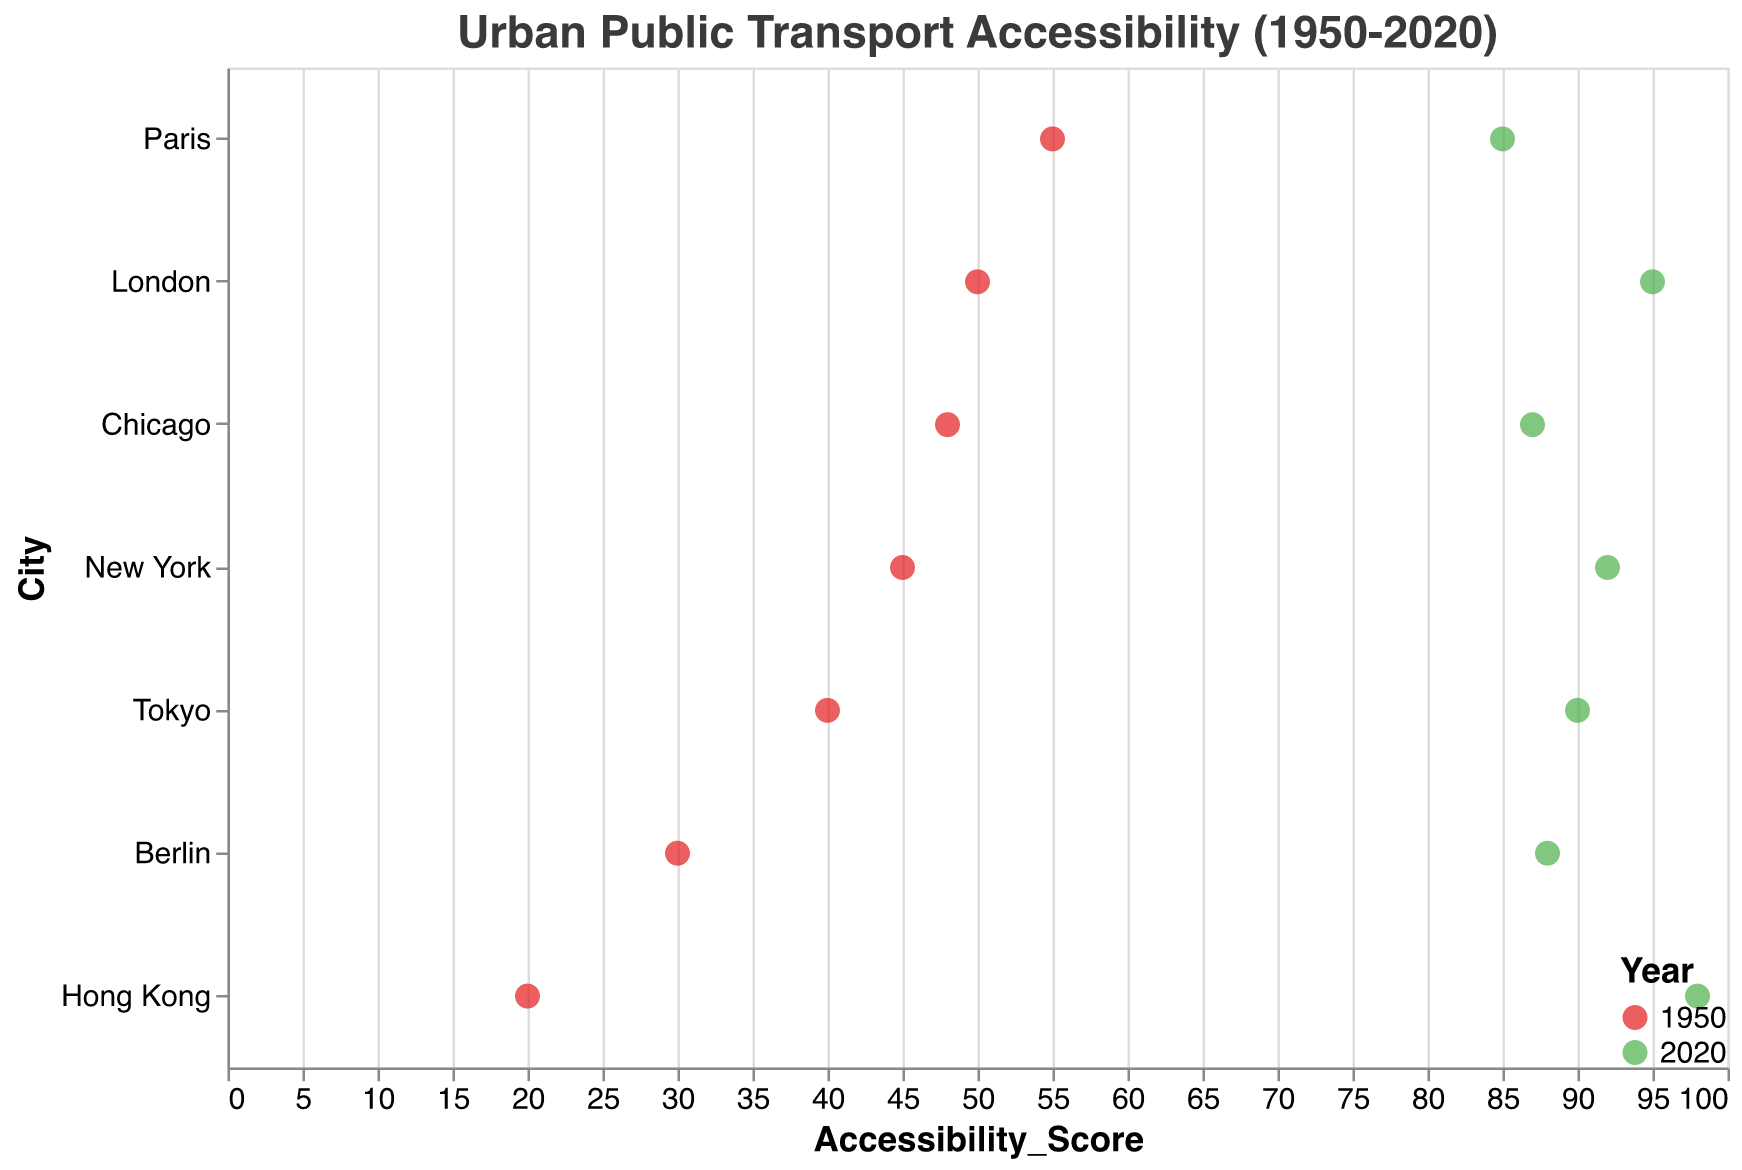What is the title of the figure? The title of the figure is "Urban Public Transport Accessibility (1950-2020)" which is displayed at the top of the plot.
Answer: Urban Public Transport Accessibility (1950-2020) Which city had the highest accessibility score in 2020? By looking at the green dots which represent the year 2020, we see Hong Kong has the highest score of 98.
Answer: Hong Kong How much did New York's accessibility score increase from 1950 to 2020? In 1950, New York had a score of 45. In 2020, it had a score of 92. The increase is calculated as 92 - 45 = 47.
Answer: 47 Which city had the smallest increase in accessibility score from 1950 to 2020? To find the smallest increase, we compare the difference in scores for each city: New York (47), London (45), Tokyo (50), Paris (30), Berlin (58), Hong Kong (78), Chicago (39). Paris had the smallest increase of 30.
Answer: Paris What is the color representation for the year 1950 and 2020 in the plot? The year 1950 is represented by red dots and the year 2020 is represented by green dots in the plot.
Answer: Red for 1950, Green for 2020 Which cities have an accessibility score of 90 or more in 2020? In 2020, looking at the green dots, the cities with accessibility scores of 90 or more are New York (92), London (95), Tokyo (90), Berlin (88, no), and Hong Kong (98).
Answer: New York, London, Tokyo, Hong Kong Identify the city with the highest improvement in accessibility score from 1950 to 2020. We calculate the differences for each city: New York (47), London (45), Tokyo (50), Paris (30), Berlin (58), Hong Kong (78), Chicago (39). Hong Kong has the highest improvement with a score increase of 78.
Answer: Hong Kong Which city had the lowest initial accessibility score in 1950? By examining the red dots for 1950, we see that Hong Kong had the lowest initial score of 20.
Answer: Hong Kong Between which two consecutive cities is the difference in accessibility score the greatest in 2020? The green dots show scores for 2020, ordered from highest to lowest: Hong Kong (98), London (95), New York (92), Tokyo (90), Berlin (88), Chicago (87), Paris (85). The greatest difference is between Hong Kong (98) and London (95), a difference of 3.
Answer: Hong Kong and London 